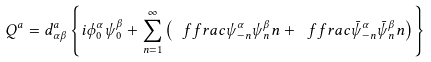Convert formula to latex. <formula><loc_0><loc_0><loc_500><loc_500>Q ^ { a } = d ^ { a } _ { \alpha \beta } \left \{ i \phi ^ { \alpha } _ { 0 } \psi ^ { \beta } _ { 0 } + \sum _ { n = 1 } ^ { \infty } \left ( \ f f r a c { \psi ^ { \alpha } _ { - n } \psi ^ { \beta } _ { n } } { n } + \ f f r a c { \bar { \psi } ^ { \alpha } _ { - n } \bar { \psi } ^ { \beta } _ { n } } { n } \right ) \right \}</formula> 